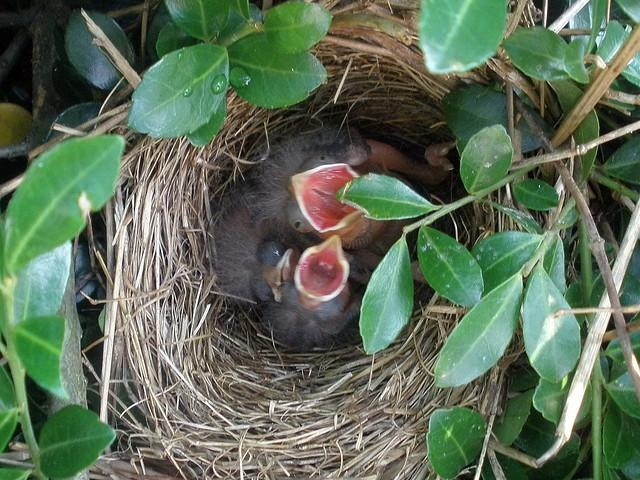Why are their mouths open? Please explain your reasoning. hungry. Baby birds often open their mouths like this to be fed by the mother bird. 